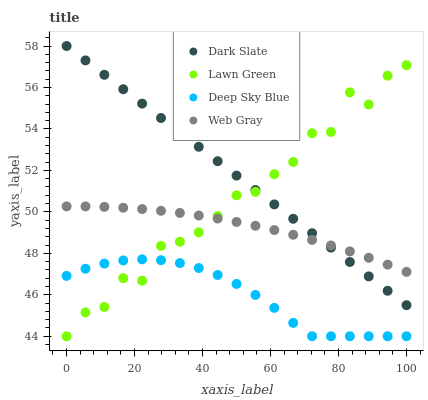Does Deep Sky Blue have the minimum area under the curve?
Answer yes or no. Yes. Does Dark Slate have the maximum area under the curve?
Answer yes or no. Yes. Does Web Gray have the minimum area under the curve?
Answer yes or no. No. Does Web Gray have the maximum area under the curve?
Answer yes or no. No. Is Dark Slate the smoothest?
Answer yes or no. Yes. Is Lawn Green the roughest?
Answer yes or no. Yes. Is Web Gray the smoothest?
Answer yes or no. No. Is Web Gray the roughest?
Answer yes or no. No. Does Deep Sky Blue have the lowest value?
Answer yes or no. Yes. Does Web Gray have the lowest value?
Answer yes or no. No. Does Dark Slate have the highest value?
Answer yes or no. Yes. Does Web Gray have the highest value?
Answer yes or no. No. Is Deep Sky Blue less than Web Gray?
Answer yes or no. Yes. Is Dark Slate greater than Deep Sky Blue?
Answer yes or no. Yes. Does Lawn Green intersect Dark Slate?
Answer yes or no. Yes. Is Lawn Green less than Dark Slate?
Answer yes or no. No. Is Lawn Green greater than Dark Slate?
Answer yes or no. No. Does Deep Sky Blue intersect Web Gray?
Answer yes or no. No. 